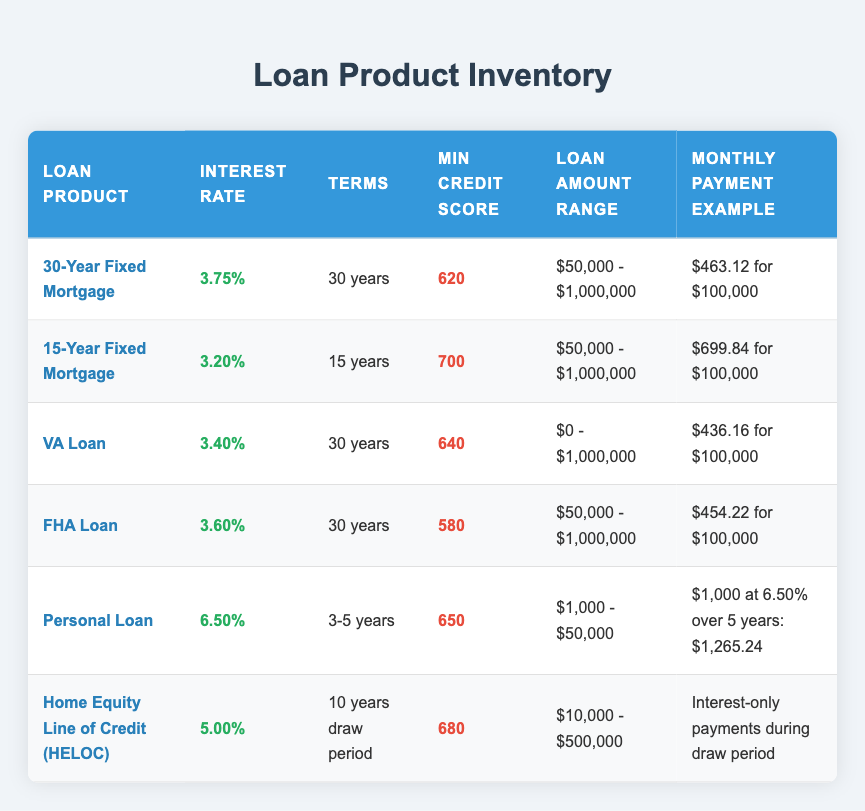What is the interest rate for the 15-Year Fixed Mortgage? The table lists the interest rates for all loan products. Looking at the row for the 15-Year Fixed Mortgage, the interest rate is given as 3.20%.
Answer: 3.20% Which loan product has the highest minimum credit score requirement? By examining the 'Min Credit Score' column, the 15-Year Fixed Mortgage has the highest minimum credit score requirement of 700, which is greater than the others listed.
Answer: 15-Year Fixed Mortgage How much is the monthly payment example for a $100,000 loan under the 30-Year Fixed Mortgage? The table provides a specific monthly payment example for the 30-Year Fixed Mortgage. It states that the monthly payment for a $100,000 loan is $463.12.
Answer: $463.12 What are the interest rates for loan products with a term of 30 years? The interest rates for loan products with a term of 30 years are found in the corresponding rows. They are as follows: 30-Year Fixed Mortgage at 3.75%, VA Loan at 3.40%, and FHA Loan at 3.60%.
Answer: 3.75%, 3.40%, 3.60% Is the interest rate for a VA Loan lower than that of a 30-Year Fixed Mortgage? A comparison of the interest rates shows that the VA Loan has an interest rate of 3.40% while the 30-Year Fixed Mortgage has a rate of 3.75%. Since 3.40% is less than 3.75%, the statement is true.
Answer: Yes What is the monthly payment example for a Personal Loan of $1,000 at 6.50% over 5 years? The table indicates that the monthly payment example for a Personal Loan is $1,000 at 6.50% over 5 years amounting to $1,265.24. This is a reference from the 'Monthly Payment Example' specific to the Personal Loan.
Answer: $1,265.24 Determine how many loan products have a minimum credit score requirement below 650. The 'Min Credit Score' column must be examined for this. The FHA Loan has a minimum credit score of 580, and the Personal Loan has a minimum credit score of 650. Thus, only the FHA Loan has a requirement below 650. The count is therefore one.
Answer: 1 What is the average interest rate for loan products with a minimum credit score below 640? The table shows the following loans with minimum credit scores below 640: FHA Loan (3.60%) and VA Loan (3.40%). First, we need to convert percentages to decimals: 0.0360 and 0.0340. Adding these gives 0.0700, and dividing by 2 gives an average rate of 0.0350, which when converted back to a percentage is 3.50%.
Answer: 3.50% 